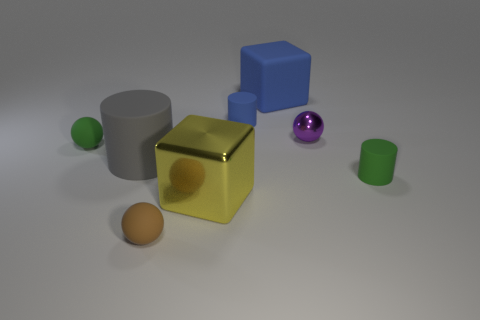Subtract 1 balls. How many balls are left? 2 Add 1 tiny matte blocks. How many objects exist? 9 Subtract all blocks. How many objects are left? 6 Add 7 big yellow cylinders. How many big yellow cylinders exist? 7 Subtract 1 brown balls. How many objects are left? 7 Subtract all blue matte objects. Subtract all big yellow cubes. How many objects are left? 5 Add 3 tiny blue matte cylinders. How many tiny blue matte cylinders are left? 4 